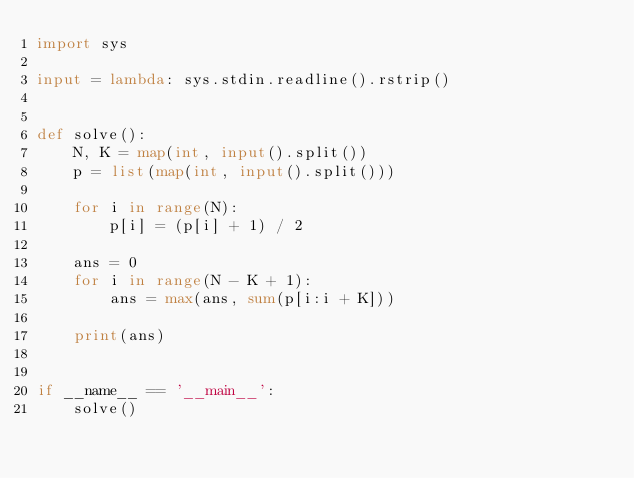Convert code to text. <code><loc_0><loc_0><loc_500><loc_500><_Python_>import sys

input = lambda: sys.stdin.readline().rstrip()


def solve():
    N, K = map(int, input().split())
    p = list(map(int, input().split()))

    for i in range(N):
        p[i] = (p[i] + 1) / 2

    ans = 0
    for i in range(N - K + 1):
        ans = max(ans, sum(p[i:i + K]))

    print(ans)


if __name__ == '__main__':
    solve()
</code> 